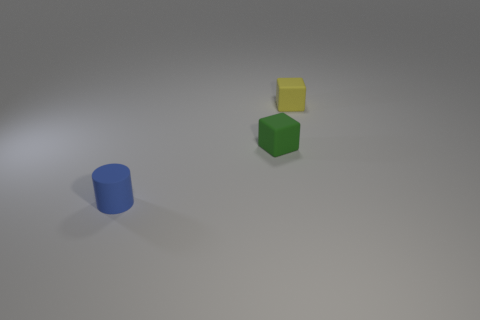Add 1 small yellow objects. How many objects exist? 4 Subtract 1 cylinders. How many cylinders are left? 0 Subtract all yellow cubes. How many cubes are left? 1 Subtract all gray balls. How many yellow blocks are left? 1 Subtract all blue things. Subtract all green matte blocks. How many objects are left? 1 Add 1 tiny green rubber blocks. How many tiny green rubber blocks are left? 2 Add 2 small yellow matte things. How many small yellow matte things exist? 3 Subtract 0 red balls. How many objects are left? 3 Subtract all cylinders. How many objects are left? 2 Subtract all brown blocks. Subtract all purple cylinders. How many blocks are left? 2 